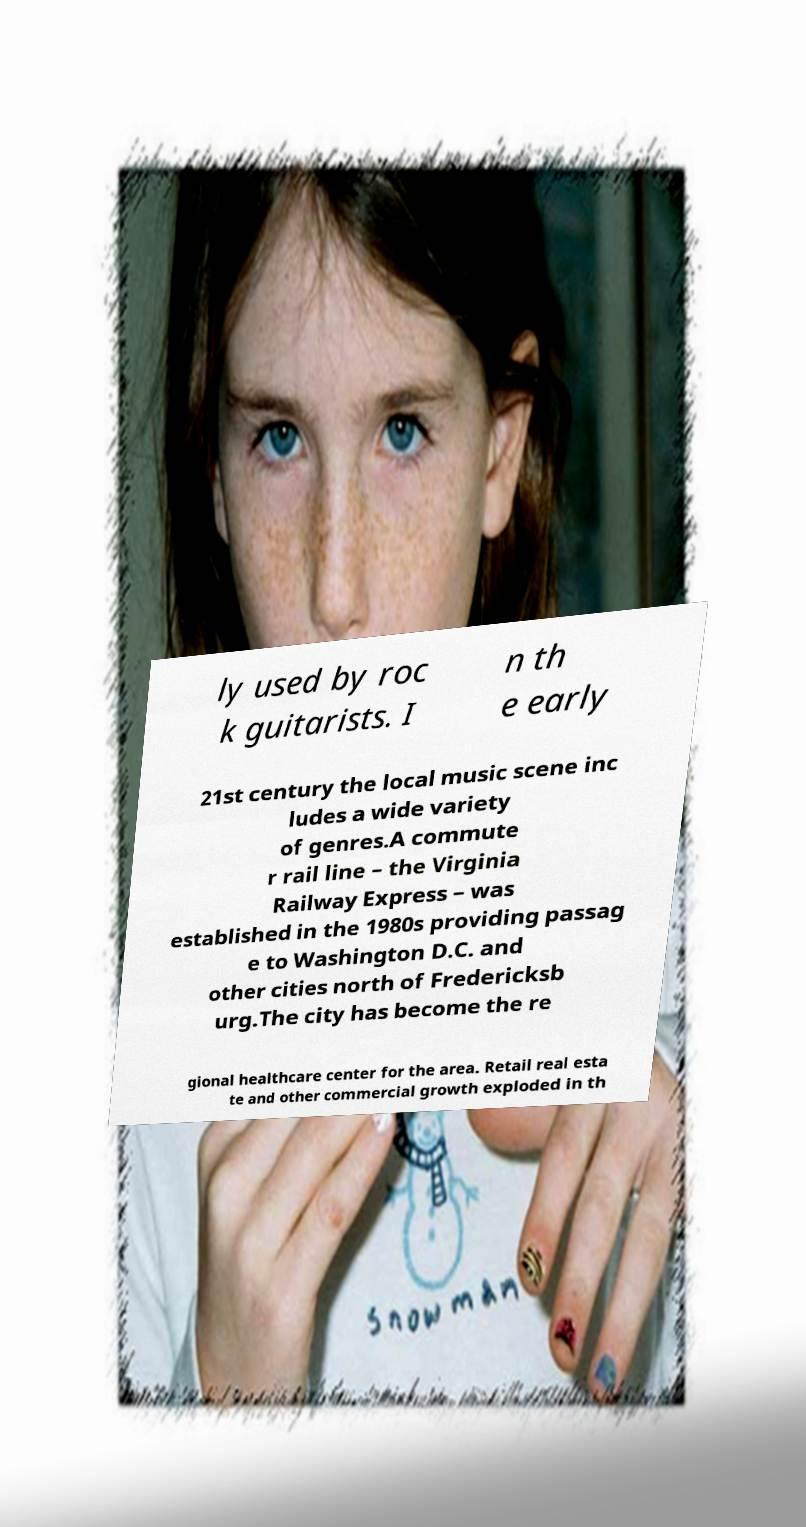Can you read and provide the text displayed in the image?This photo seems to have some interesting text. Can you extract and type it out for me? ly used by roc k guitarists. I n th e early 21st century the local music scene inc ludes a wide variety of genres.A commute r rail line – the Virginia Railway Express – was established in the 1980s providing passag e to Washington D.C. and other cities north of Fredericksb urg.The city has become the re gional healthcare center for the area. Retail real esta te and other commercial growth exploded in th 